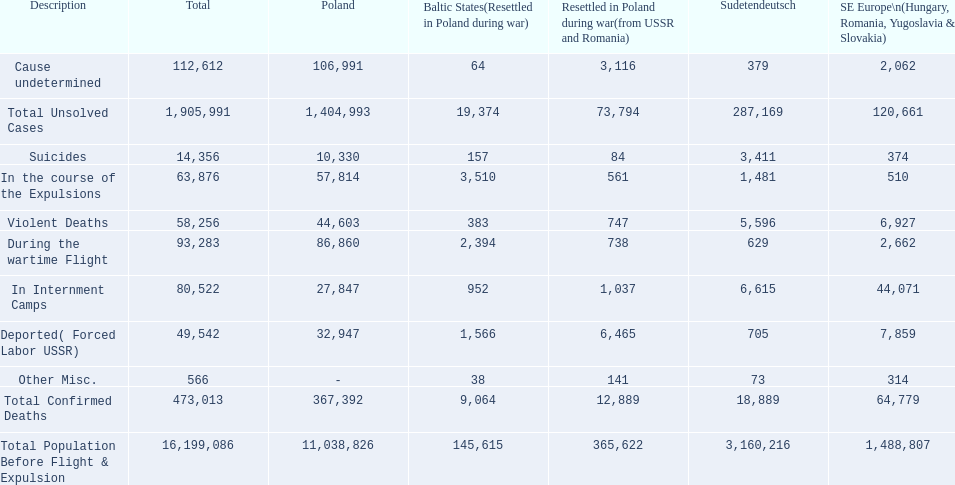What are all of the descriptions? Total Population Before Flight & Expulsion, Violent Deaths, Suicides, Deported( Forced Labor USSR), In Internment Camps, During the wartime Flight, In the course of the Expulsions, Cause undetermined, Other Misc., Total Confirmed Deaths, Total Unsolved Cases. What were their total number of deaths? 16,199,086, 58,256, 14,356, 49,542, 80,522, 93,283, 63,876, 112,612, 566, 473,013, 1,905,991. What about just from violent deaths? 58,256. 